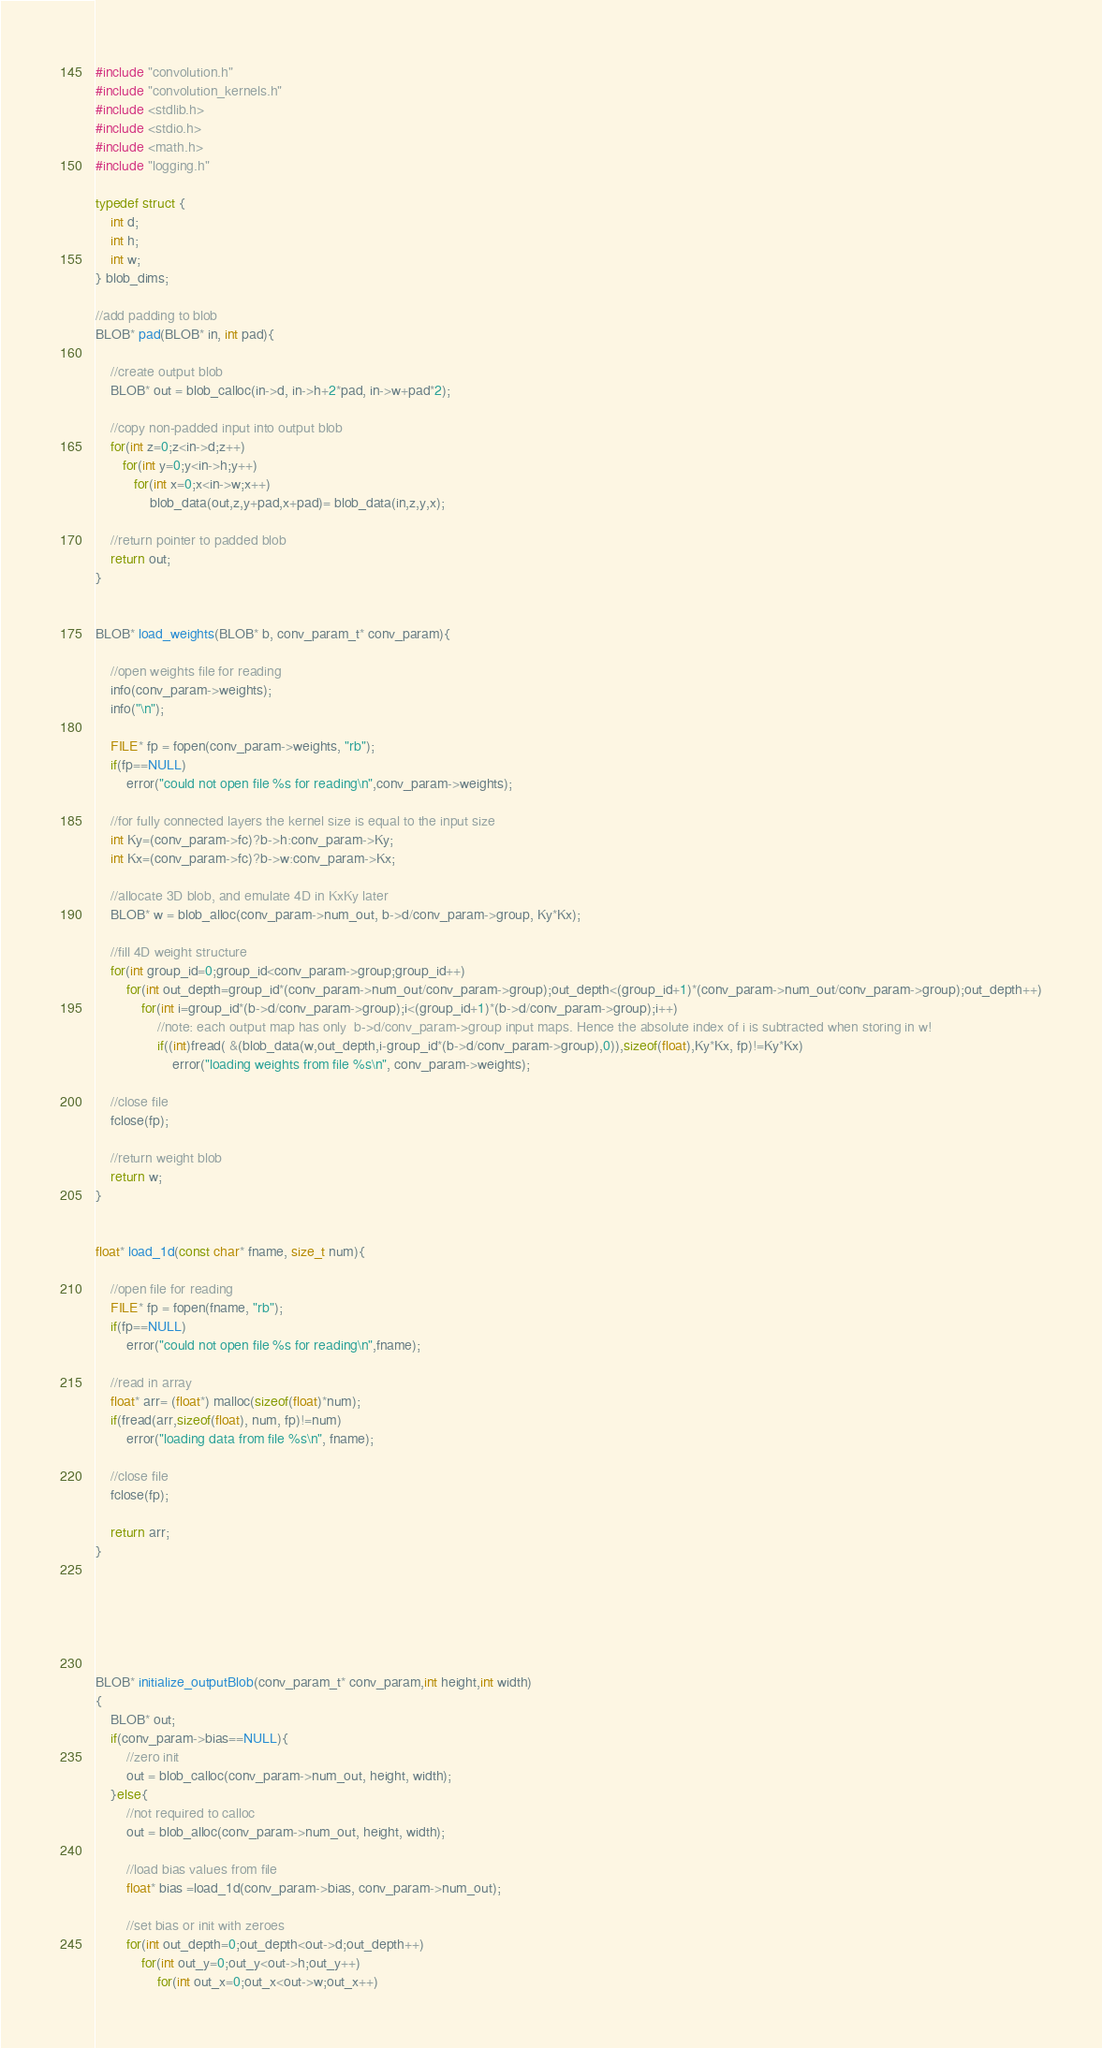<code> <loc_0><loc_0><loc_500><loc_500><_Cuda_>#include "convolution.h"
#include "convolution_kernels.h"
#include <stdlib.h>
#include <stdio.h>
#include <math.h>
#include "logging.h"

typedef struct {
    int d;
    int h;
    int w;
} blob_dims;

//add padding to blob
BLOB* pad(BLOB* in, int pad){

    //create output blob
    BLOB* out = blob_calloc(in->d, in->h+2*pad, in->w+pad*2);

    //copy non-padded input into output blob
    for(int z=0;z<in->d;z++)
       for(int y=0;y<in->h;y++)
          for(int x=0;x<in->w;x++)
              blob_data(out,z,y+pad,x+pad)= blob_data(in,z,y,x);

    //return pointer to padded blob
    return out;
}


BLOB* load_weights(BLOB* b, conv_param_t* conv_param){

    //open weights file for reading
    info(conv_param->weights);
    info("\n");
    
    FILE* fp = fopen(conv_param->weights, "rb");
    if(fp==NULL)
        error("could not open file %s for reading\n",conv_param->weights);

    //for fully connected layers the kernel size is equal to the input size
    int Ky=(conv_param->fc)?b->h:conv_param->Ky;
    int Kx=(conv_param->fc)?b->w:conv_param->Kx;

    //allocate 3D blob, and emulate 4D in KxKy later
    BLOB* w = blob_alloc(conv_param->num_out, b->d/conv_param->group, Ky*Kx);

    //fill 4D weight structure
    for(int group_id=0;group_id<conv_param->group;group_id++)
        for(int out_depth=group_id*(conv_param->num_out/conv_param->group);out_depth<(group_id+1)*(conv_param->num_out/conv_param->group);out_depth++)
            for(int i=group_id*(b->d/conv_param->group);i<(group_id+1)*(b->d/conv_param->group);i++)
                //note: each output map has only  b->d/conv_param->group input maps. Hence the absolute index of i is subtracted when storing in w!
                if((int)fread( &(blob_data(w,out_depth,i-group_id*(b->d/conv_param->group),0)),sizeof(float),Ky*Kx, fp)!=Ky*Kx)
                    error("loading weights from file %s\n", conv_param->weights);

    //close file
    fclose(fp);

    //return weight blob
    return w;
}


float* load_1d(const char* fname, size_t num){

    //open file for reading
    FILE* fp = fopen(fname, "rb");
    if(fp==NULL)
        error("could not open file %s for reading\n",fname);

    //read in array
    float* arr= (float*) malloc(sizeof(float)*num);
    if(fread(arr,sizeof(float), num, fp)!=num)
        error("loading data from file %s\n", fname);

    //close file
    fclose(fp);

    return arr;
}






BLOB* initialize_outputBlob(conv_param_t* conv_param,int height,int width)
{
    BLOB* out;
    if(conv_param->bias==NULL){
        //zero init
        out = blob_calloc(conv_param->num_out, height, width);
    }else{
        //not required to calloc
        out = blob_alloc(conv_param->num_out, height, width);

        //load bias values from file
        float* bias =load_1d(conv_param->bias, conv_param->num_out);

        //set bias or init with zeroes
        for(int out_depth=0;out_depth<out->d;out_depth++)
            for(int out_y=0;out_y<out->h;out_y++)
                for(int out_x=0;out_x<out->w;out_x++)</code> 